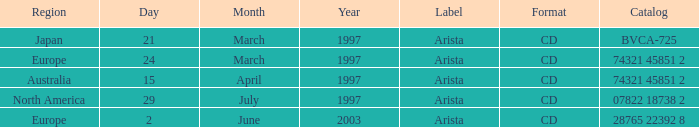What's listed for the Label with a Date of 29 July 1997? Arista. 